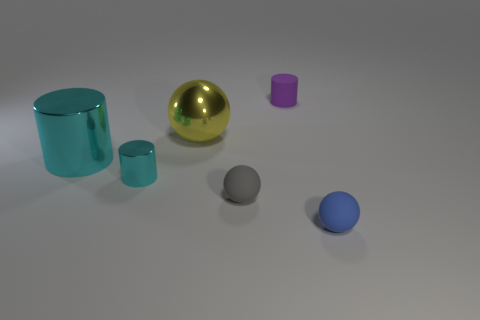There is a small cyan thing that is the same shape as the big cyan metal object; what is its material?
Ensure brevity in your answer.  Metal. There is a tiny object that is the same color as the large cylinder; what shape is it?
Provide a short and direct response. Cylinder. Does the large metal object on the left side of the tiny cyan metal cylinder have the same color as the small metal cylinder?
Offer a terse response. Yes. What is the small object that is on the right side of the matte cylinder made of?
Give a very brief answer. Rubber. There is a small object that is both to the left of the small purple object and on the right side of the tiny metal object; what is its material?
Offer a terse response. Rubber. There is a rubber sphere that is to the left of the blue rubber thing; does it have the same size as the big cyan object?
Ensure brevity in your answer.  No. The big cyan shiny object is what shape?
Offer a very short reply. Cylinder. How many metallic things are the same shape as the purple rubber thing?
Keep it short and to the point. 2. What number of things are both on the right side of the purple thing and to the left of the tiny purple rubber thing?
Your response must be concise. 0. The matte cylinder is what color?
Offer a very short reply. Purple. 